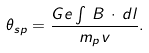Convert formula to latex. <formula><loc_0><loc_0><loc_500><loc_500>\theta _ { s p } = \frac { G e \int { \, B \, \cdot \, d l } } { m _ { p } v } .</formula> 